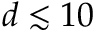Convert formula to latex. <formula><loc_0><loc_0><loc_500><loc_500>d \lesssim 1 0</formula> 